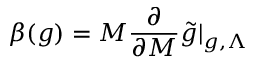<formula> <loc_0><loc_0><loc_500><loc_500>\beta ( g ) = M \frac { \partial } { \partial M } \tilde { g } | _ { g , \Lambda }</formula> 